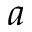Convert formula to latex. <formula><loc_0><loc_0><loc_500><loc_500>a</formula> 